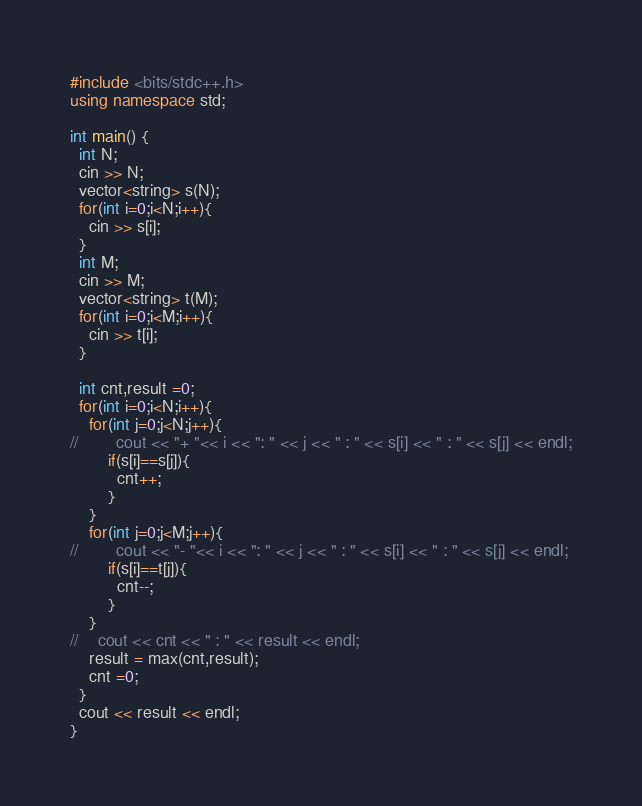Convert code to text. <code><loc_0><loc_0><loc_500><loc_500><_C++_>#include <bits/stdc++.h>
using namespace std;

int main() {
  int N;
  cin >> N;
  vector<string> s(N);
  for(int i=0;i<N;i++){
    cin >> s[i];
  }
  int M;
  cin >> M;
  vector<string> t(M);
  for(int i=0;i<M;i++){
    cin >> t[i];
  }
  
  int cnt,result =0;
  for(int i=0;i<N;i++){
    for(int j=0;j<N;j++){
//        cout << "+ "<< i << ": " << j << " : " << s[i] << " : " << s[j] << endl;
        if(s[i]==s[j]){
          cnt++;
        }
    }
    for(int j=0;j<M;j++){
//        cout << "- "<< i << ": " << j << " : " << s[i] << " : " << s[j] << endl;
        if(s[i]==t[j]){
          cnt--;
        }
    }  
//    cout << cnt << " : " << result << endl;
    result = max(cnt,result);
    cnt =0;
  }
  cout << result << endl;
}</code> 